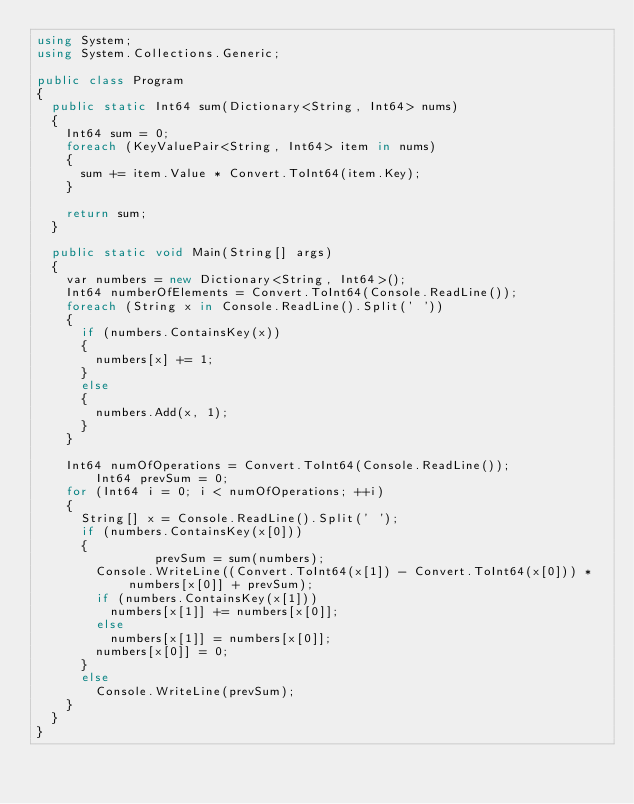<code> <loc_0><loc_0><loc_500><loc_500><_C#_>using System;
using System.Collections.Generic;

public class Program
{
	public static Int64 sum(Dictionary<String, Int64> nums)
	{
		Int64 sum = 0;
		foreach (KeyValuePair<String, Int64> item in nums)
		{
			sum += item.Value * Convert.ToInt64(item.Key);
		}

		return sum;
	}

	public static void Main(String[] args)
	{
		var numbers = new Dictionary<String, Int64>();
		Int64 numberOfElements = Convert.ToInt64(Console.ReadLine());
		foreach (String x in Console.ReadLine().Split(' '))
		{
			if (numbers.ContainsKey(x))
			{
				numbers[x] += 1;
			}
			else
			{
				numbers.Add(x, 1);
			}
		}

		Int64 numOfOperations = Convert.ToInt64(Console.ReadLine());
      	Int64 prevSum = 0;
		for (Int64 i = 0; i < numOfOperations; ++i)
		{
			String[] x = Console.ReadLine().Split(' ');
			if (numbers.ContainsKey(x[0]))
			{
              	prevSum = sum(numbers);
				Console.WriteLine((Convert.ToInt64(x[1]) - Convert.ToInt64(x[0])) * numbers[x[0]] + prevSum);
				if (numbers.ContainsKey(x[1]))
					numbers[x[1]] += numbers[x[0]];
				else
					numbers[x[1]] = numbers[x[0]];
				numbers[x[0]] = 0;
			}
			else
				Console.WriteLine(prevSum);
		}
	}
}</code> 